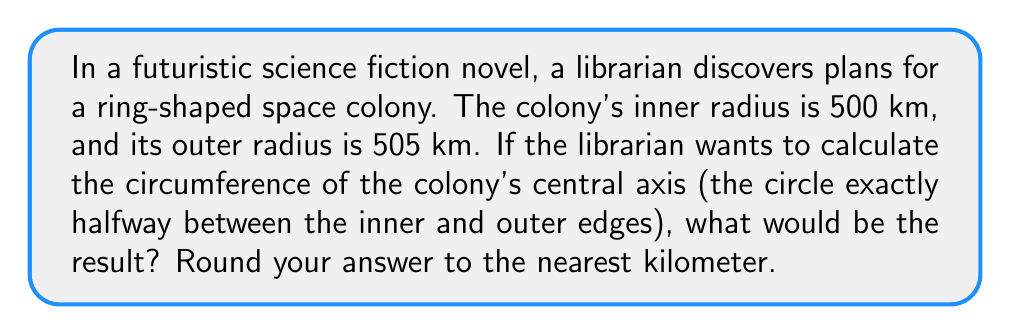Can you solve this math problem? To solve this problem, we need to follow these steps:

1. Find the radius of the central axis:
   The central axis is halfway between the inner and outer edges.
   $$r_{central} = \frac{r_{inner} + r_{outer}}{2} = \frac{500 + 505}{2} = 502.5 \text{ km}$$

2. Use the formula for circumference:
   The circumference of a circle is given by $C = 2\pi r$, where $r$ is the radius.
   $$C = 2\pi r_{central} = 2\pi(502.5)$$

3. Calculate the result:
   $$C = 2 \times 3.14159... \times 502.5 \approx 3156.59 \text{ km}$$

4. Round to the nearest kilometer:
   3156.59 km rounds to 3157 km

[asy]
import geometry;

size(200);
pair O = (0,0);
draw(circle(O, 100), blue);
draw(circle(O, 101), blue);
draw(circle(O, 100.5), red+dashed);
label("Inner edge", (-71,-71), blue);
label("Outer edge", (71,71), blue);
label("Central axis", (0,100.5), red);
[/asy]
Answer: The circumference of the space colony's central axis is approximately 3157 km. 